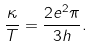Convert formula to latex. <formula><loc_0><loc_0><loc_500><loc_500>\frac { \kappa } { T } = \frac { 2 e ^ { 2 } \pi } { 3 h } .</formula> 